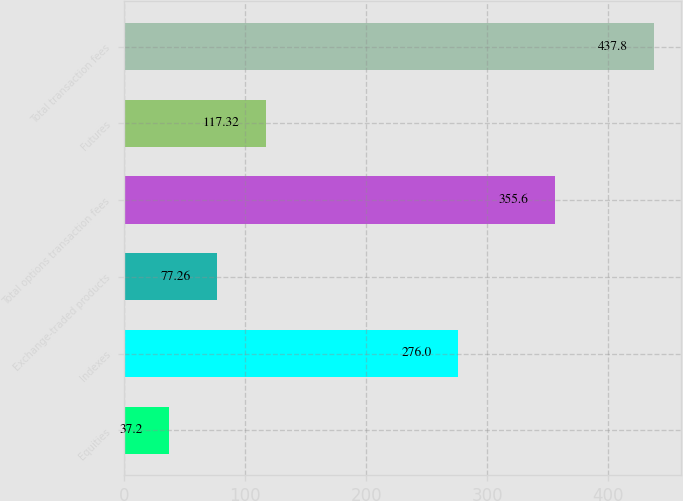Convert chart to OTSL. <chart><loc_0><loc_0><loc_500><loc_500><bar_chart><fcel>Equities<fcel>Indexes<fcel>Exchange-traded products<fcel>Total options transaction fees<fcel>Futures<fcel>Total transaction fees<nl><fcel>37.2<fcel>276<fcel>77.26<fcel>355.6<fcel>117.32<fcel>437.8<nl></chart> 